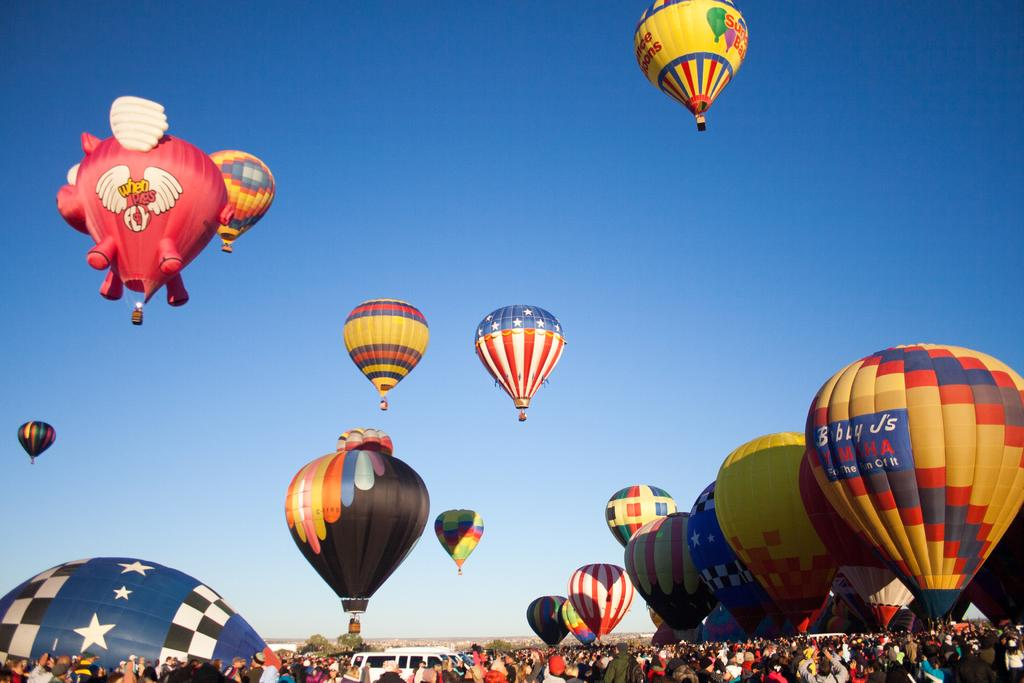<image>
Write a terse but informative summary of the picture. the letter J is on the front of the hot air balloon 